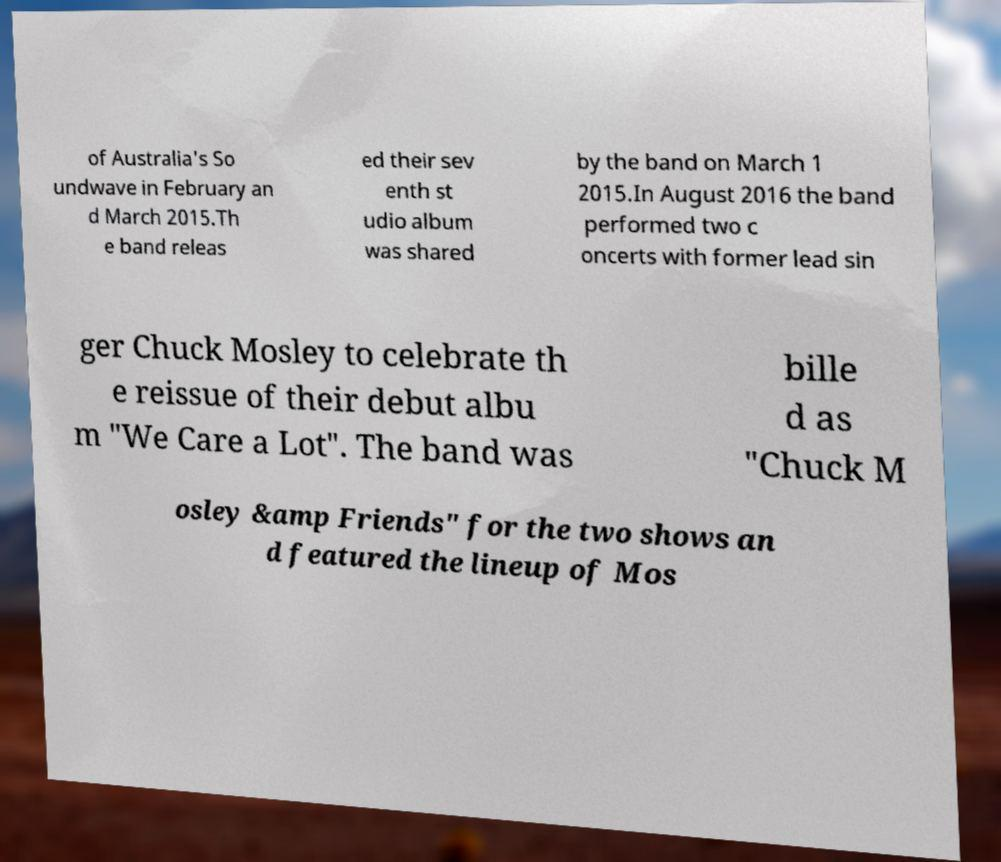Can you accurately transcribe the text from the provided image for me? of Australia's So undwave in February an d March 2015.Th e band releas ed their sev enth st udio album was shared by the band on March 1 2015.In August 2016 the band performed two c oncerts with former lead sin ger Chuck Mosley to celebrate th e reissue of their debut albu m "We Care a Lot". The band was bille d as "Chuck M osley &amp Friends" for the two shows an d featured the lineup of Mos 